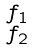Convert formula to latex. <formula><loc_0><loc_0><loc_500><loc_500>\begin{smallmatrix} f _ { 1 } \\ f _ { 2 } \end{smallmatrix}</formula> 